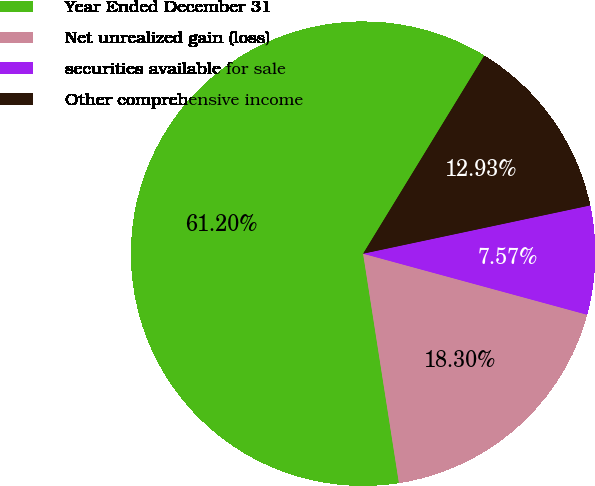Convert chart to OTSL. <chart><loc_0><loc_0><loc_500><loc_500><pie_chart><fcel>Year Ended December 31<fcel>Net unrealized gain (loss)<fcel>securities available for sale<fcel>Other comprehensive income<nl><fcel>61.21%<fcel>18.3%<fcel>7.57%<fcel>12.93%<nl></chart> 